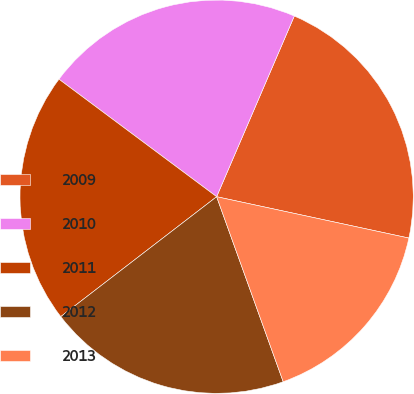<chart> <loc_0><loc_0><loc_500><loc_500><pie_chart><fcel>2009<fcel>2010<fcel>2011<fcel>2012<fcel>2013<nl><fcel>21.91%<fcel>21.27%<fcel>20.63%<fcel>20.06%<fcel>16.13%<nl></chart> 